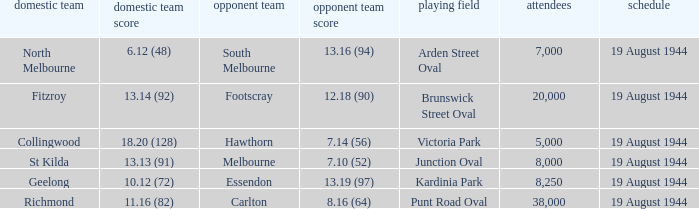What is Fitzroy's Home team score? 13.14 (92). 